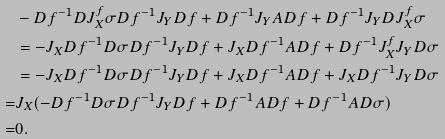Convert formula to latex. <formula><loc_0><loc_0><loc_500><loc_500>& - D f ^ { - 1 } D J _ { X } ^ { f } \sigma D f ^ { - 1 } J _ { Y } D f + D f ^ { - 1 } J _ { Y } A D f + D f ^ { - 1 } J _ { Y } D J _ { X } ^ { f } \sigma \\ & = - J _ { X } D f ^ { - 1 } D \sigma D f ^ { - 1 } J _ { Y } D f + J _ { X } D f ^ { - 1 } A D f + D f ^ { - 1 } J _ { X } ^ { f } J _ { Y } D \sigma \\ & = - J _ { X } D f ^ { - 1 } D \sigma D f ^ { - 1 } J _ { Y } D f + J _ { X } D f ^ { - 1 } A D f + J _ { X } D f ^ { - 1 } J _ { Y } D \sigma \\ = & J _ { X } ( - D f ^ { - 1 } D \sigma D f ^ { - 1 } J _ { Y } D f + D f ^ { - 1 } A D f + D f ^ { - 1 } A D \sigma ) \\ = & 0 .</formula> 